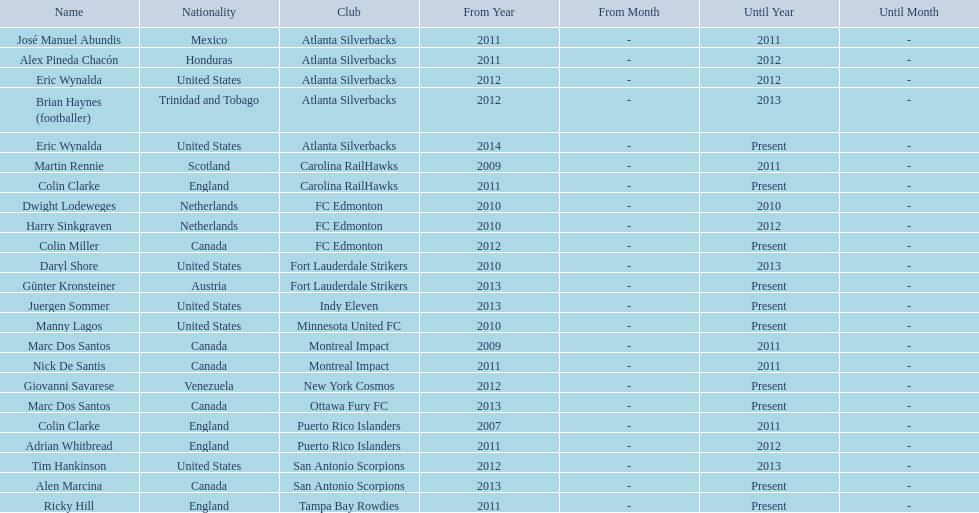Who coached the silverbacks longer, abundis or chacon? Chacon. 